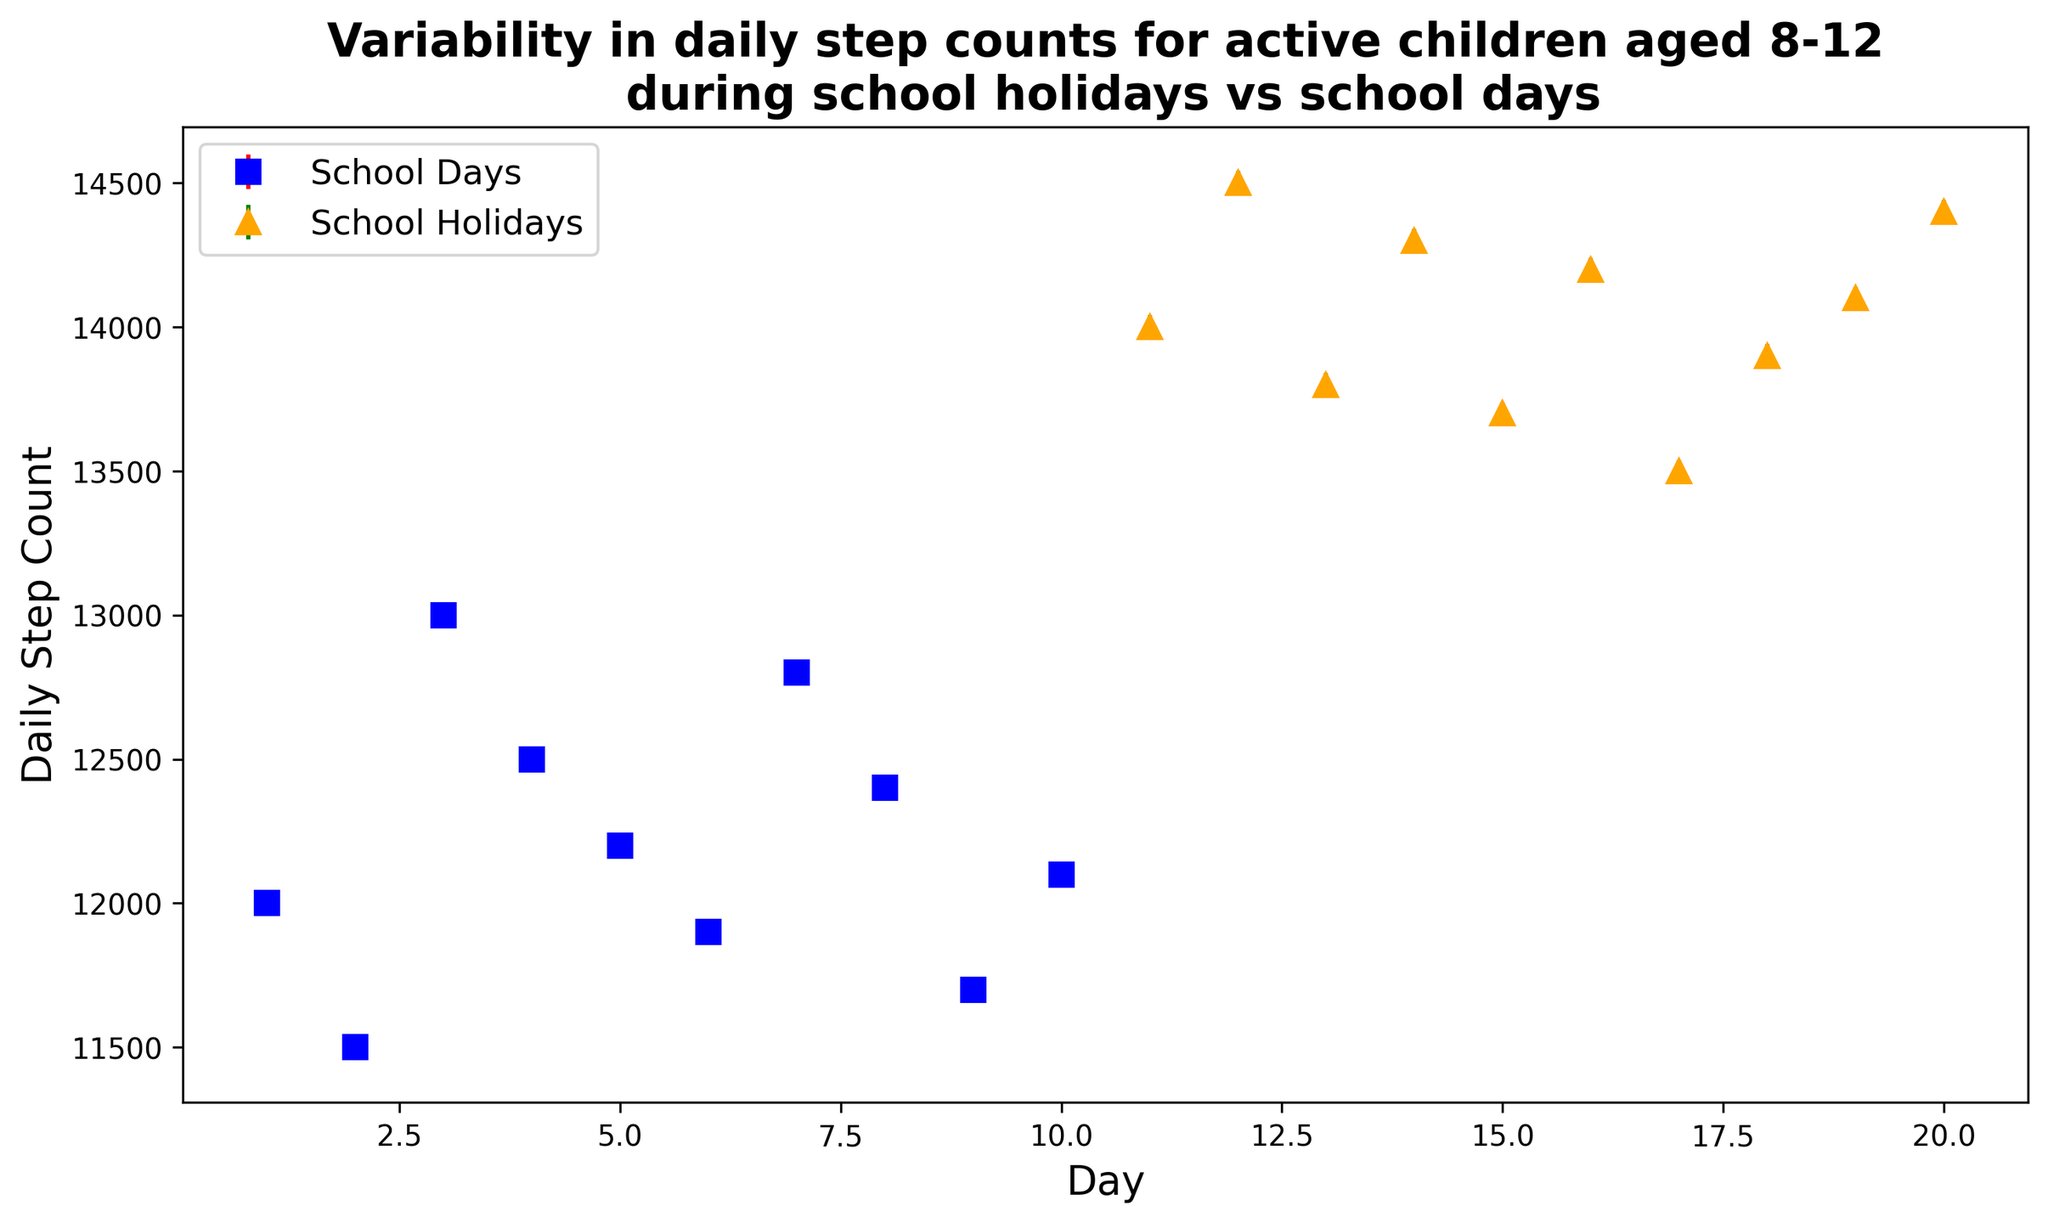What's the average daily step count on school holidays? First, sum up the daily step counts for school holidays: \( 14000 + 14500 + 13800 + 14300 + 13700 + 14200 + 13500 + 13900 + 14100 + 14400 = 141400 \). There are 10 data points, so the average step count is \( 141400 / 10 = 14140 \) steps.
Answer: 14140 Which condition has the higher maximum step count, school days or school holidays? The maximum step count for school days is 13000, while for school holidays, it is 14500. Therefore, school holidays have a higher maximum step count.
Answer: School holidays On which conditions do children have more variability in their daily step count? The error bars on school holidays are larger compared to school days. This indicates that there is more variability in the daily step counts during school holidays.
Answer: School holidays What is the difference in the average step count between school days and school holidays? Average step count for school days: \( \frac{12000 + 11500 + 13000 + 12500 + 12200 + 11900 + 12800 + 12400 + 11700 + 12100}{10} = 12210 \). Average step count for school holidays: 14140 steps. The difference is \( 14140 - 12210 = 1930 \) steps.
Answer: 1930 Which day has the least variability in step count on school days? Variance for school days: \[ \text{Day 1: } \sqrt{1500}, \text{Day 2: } \sqrt{1400}, \text{Day 3: } \sqrt{1600}, \text{Day 4: } \sqrt{1550}, \text{Day 5: } \sqrt{1500}, \text{Day 6: } \sqrt{1480}, \text{Day 7: } \sqrt{1580}, \text{Day 8: } \sqrt{1520}, \text{Day 9: } \sqrt{1450}, \text{Day 10: } \sqrt{1510} \]. Day 2, with \(\sqrt{1400} \approx 37.42\), has the least variability.
Answer: Day 2 How does the step count trend for school holidays compare to school days? Visually, step counts during school holidays appear consistently higher than during school days, and there is a noticeable increase in variability (larger error bars) during holidays as well.
Answer: Higher and more variable during holidays Which day within the school holidays has the maximum step count? The highest point within the school holidays section is on Day 12 with 14500 steps.
Answer: Day 12 Is the overall trend for both conditions steadily increasing, decreasing, or fluctuating? Both conditions show fluctuations in the daily step counts rather than a steady increase or decrease.
Answer: Fluctuating On which day during school days is the step count exactly 12500? By referring to the school days plot, on Day 4, the step count is exactly 12500.
Answer: Day 4 